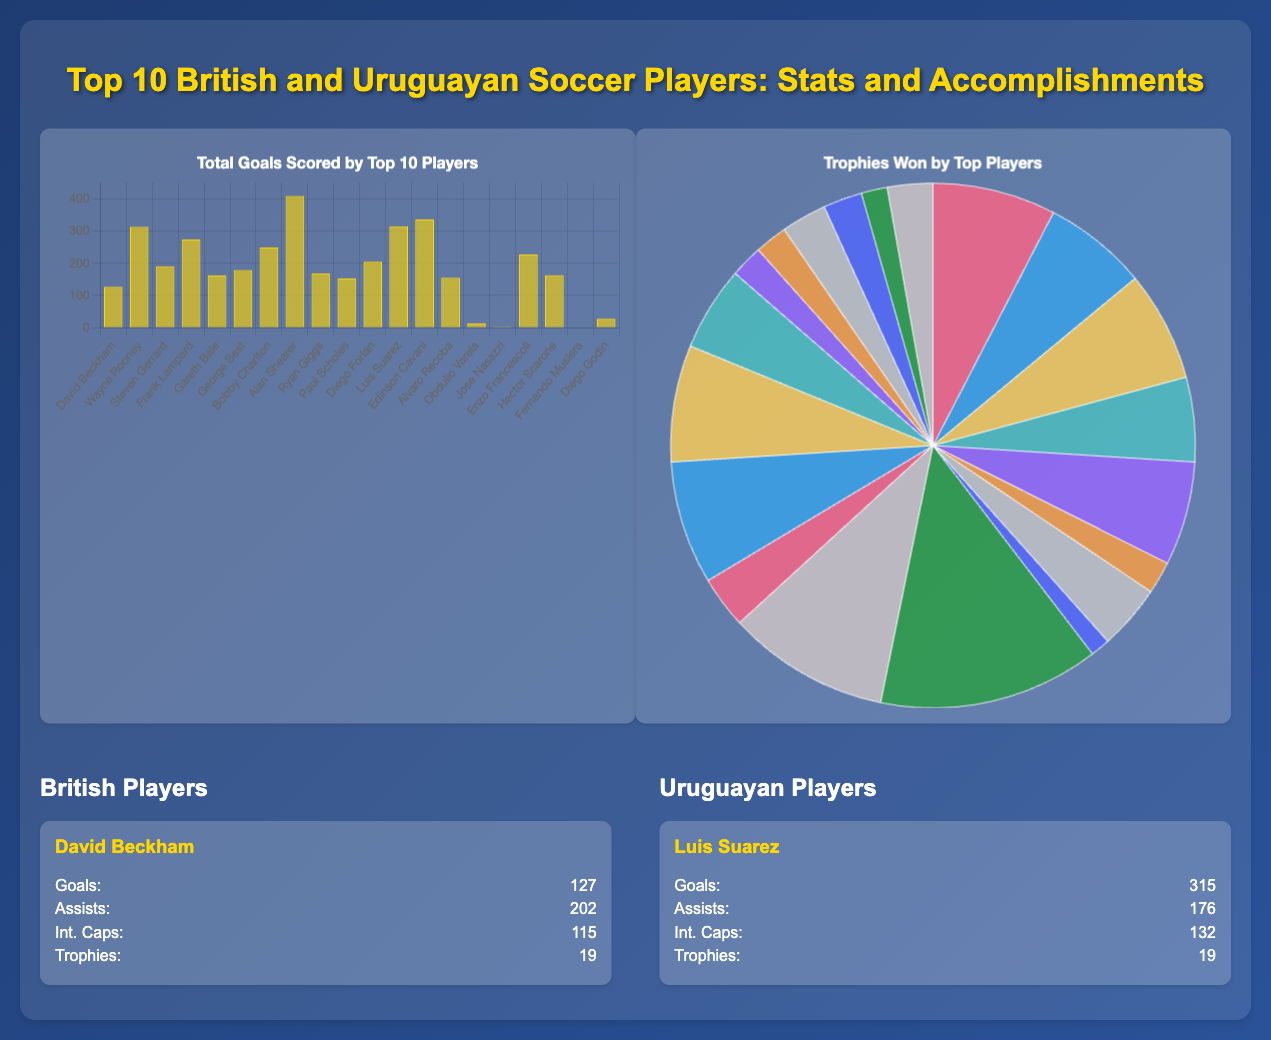What is the highest number of goals scored by a British player? The highest number of goals scored by a British player in the document is 409 by Alan Shearer.
Answer: 409 Who has the most international caps among the listed Uruguayan players? The player with the most international caps among the Uruguayan players is Luis Suarez with 132 caps.
Answer: 132 How many trophies did David Beckham win? David Beckham won a total of 19 trophies, as mentioned in his player card.
Answer: 19 Which player has the highest total goals scored among the top 10 players listed? The player with the highest total goals scored among the top players is Alan Shearer with 409 goals.
Answer: Alan Shearer How many assists did Wayne Rooney have? Wayne Rooney had a total of 228 assists according to the data in the document.
Answer: 228 What is the total number of trophies won by Luis Suarez? Luis Suarez won 19 trophies, as noted in his player card.
Answer: 19 Which Uruguayan player has the least goals? The Uruguayan player with the least goals is Obdulio Varela, with only 13 goals scored.
Answer: Obdulio Varela What type of chart is used to display the trophies won by players? The trophies won by players are displayed using a pie chart in the document.
Answer: Pie chart What is the color representing total goals scored in the goals chart? The color representing total goals scored in the goals chart is gold (rgba(255, 215, 0, 0.6)).
Answer: Gold 